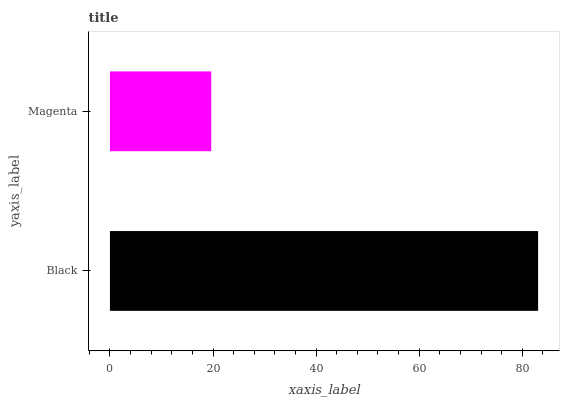Is Magenta the minimum?
Answer yes or no. Yes. Is Black the maximum?
Answer yes or no. Yes. Is Magenta the maximum?
Answer yes or no. No. Is Black greater than Magenta?
Answer yes or no. Yes. Is Magenta less than Black?
Answer yes or no. Yes. Is Magenta greater than Black?
Answer yes or no. No. Is Black less than Magenta?
Answer yes or no. No. Is Black the high median?
Answer yes or no. Yes. Is Magenta the low median?
Answer yes or no. Yes. Is Magenta the high median?
Answer yes or no. No. Is Black the low median?
Answer yes or no. No. 